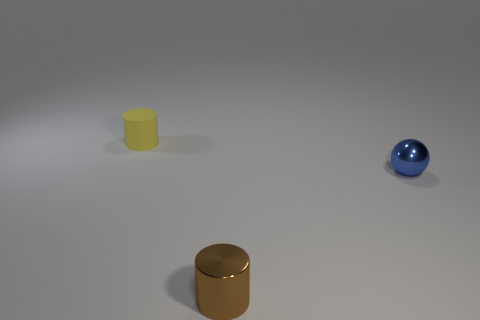What is the color of the other small object that is made of the same material as the brown thing?
Offer a terse response. Blue. Is the number of large yellow rubber cylinders less than the number of brown metal things?
Make the answer very short. Yes. How many brown things are small cylinders or tiny shiny things?
Provide a succinct answer. 1. What number of cylinders are on the left side of the brown shiny object and in front of the yellow rubber cylinder?
Your answer should be compact. 0. Is the tiny blue thing made of the same material as the yellow cylinder?
Your answer should be very brief. No. There is a blue metallic object that is the same size as the rubber cylinder; what is its shape?
Give a very brief answer. Sphere. Is the number of brown metal objects greater than the number of yellow shiny cubes?
Keep it short and to the point. Yes. What material is the small object that is on the left side of the blue object and behind the small brown metallic cylinder?
Offer a very short reply. Rubber. How many other things are there of the same material as the small sphere?
Your answer should be compact. 1. How many small shiny cylinders are the same color as the small sphere?
Offer a terse response. 0. 